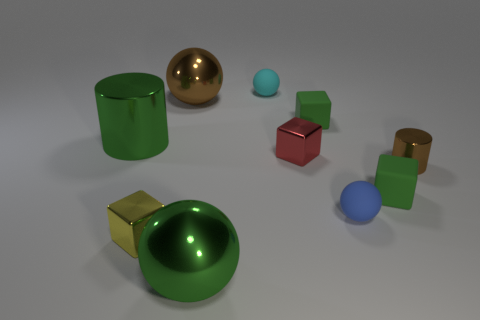What is the size of the green metal object that is in front of the small cube left of the small shiny cube that is behind the brown cylinder?
Provide a short and direct response. Large. Are there an equal number of big balls to the right of the red metallic thing and yellow things that are behind the blue rubber thing?
Provide a succinct answer. Yes. There is a brown ball that is made of the same material as the big green ball; what is its size?
Give a very brief answer. Large. What is the color of the small cylinder?
Provide a short and direct response. Brown. What number of small rubber cubes are the same color as the large metal cylinder?
Your answer should be compact. 2. There is a cylinder that is the same size as the brown shiny sphere; what is its material?
Your response must be concise. Metal. Are there any big metallic cylinders in front of the green rubber block that is in front of the red metal cube?
Keep it short and to the point. No. How many other things are the same color as the big cylinder?
Provide a succinct answer. 3. How big is the cyan matte ball?
Ensure brevity in your answer.  Small. Are there any large cyan matte cubes?
Provide a short and direct response. No. 